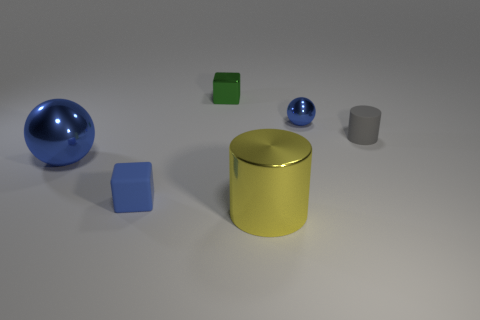Add 4 gray metal balls. How many objects exist? 10 Subtract all blocks. How many objects are left? 4 Add 6 small balls. How many small balls exist? 7 Subtract 0 red blocks. How many objects are left? 6 Subtract all tiny brown metallic cubes. Subtract all large objects. How many objects are left? 4 Add 6 blue cubes. How many blue cubes are left? 7 